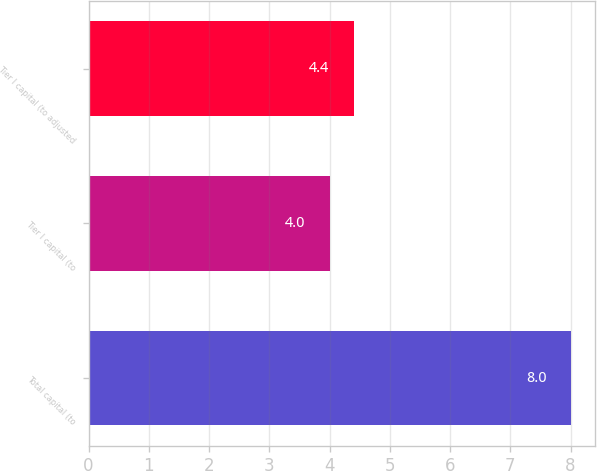<chart> <loc_0><loc_0><loc_500><loc_500><bar_chart><fcel>Total capital (to<fcel>Tier I capital (to<fcel>Tier I capital (to adjusted<nl><fcel>8<fcel>4<fcel>4.4<nl></chart> 